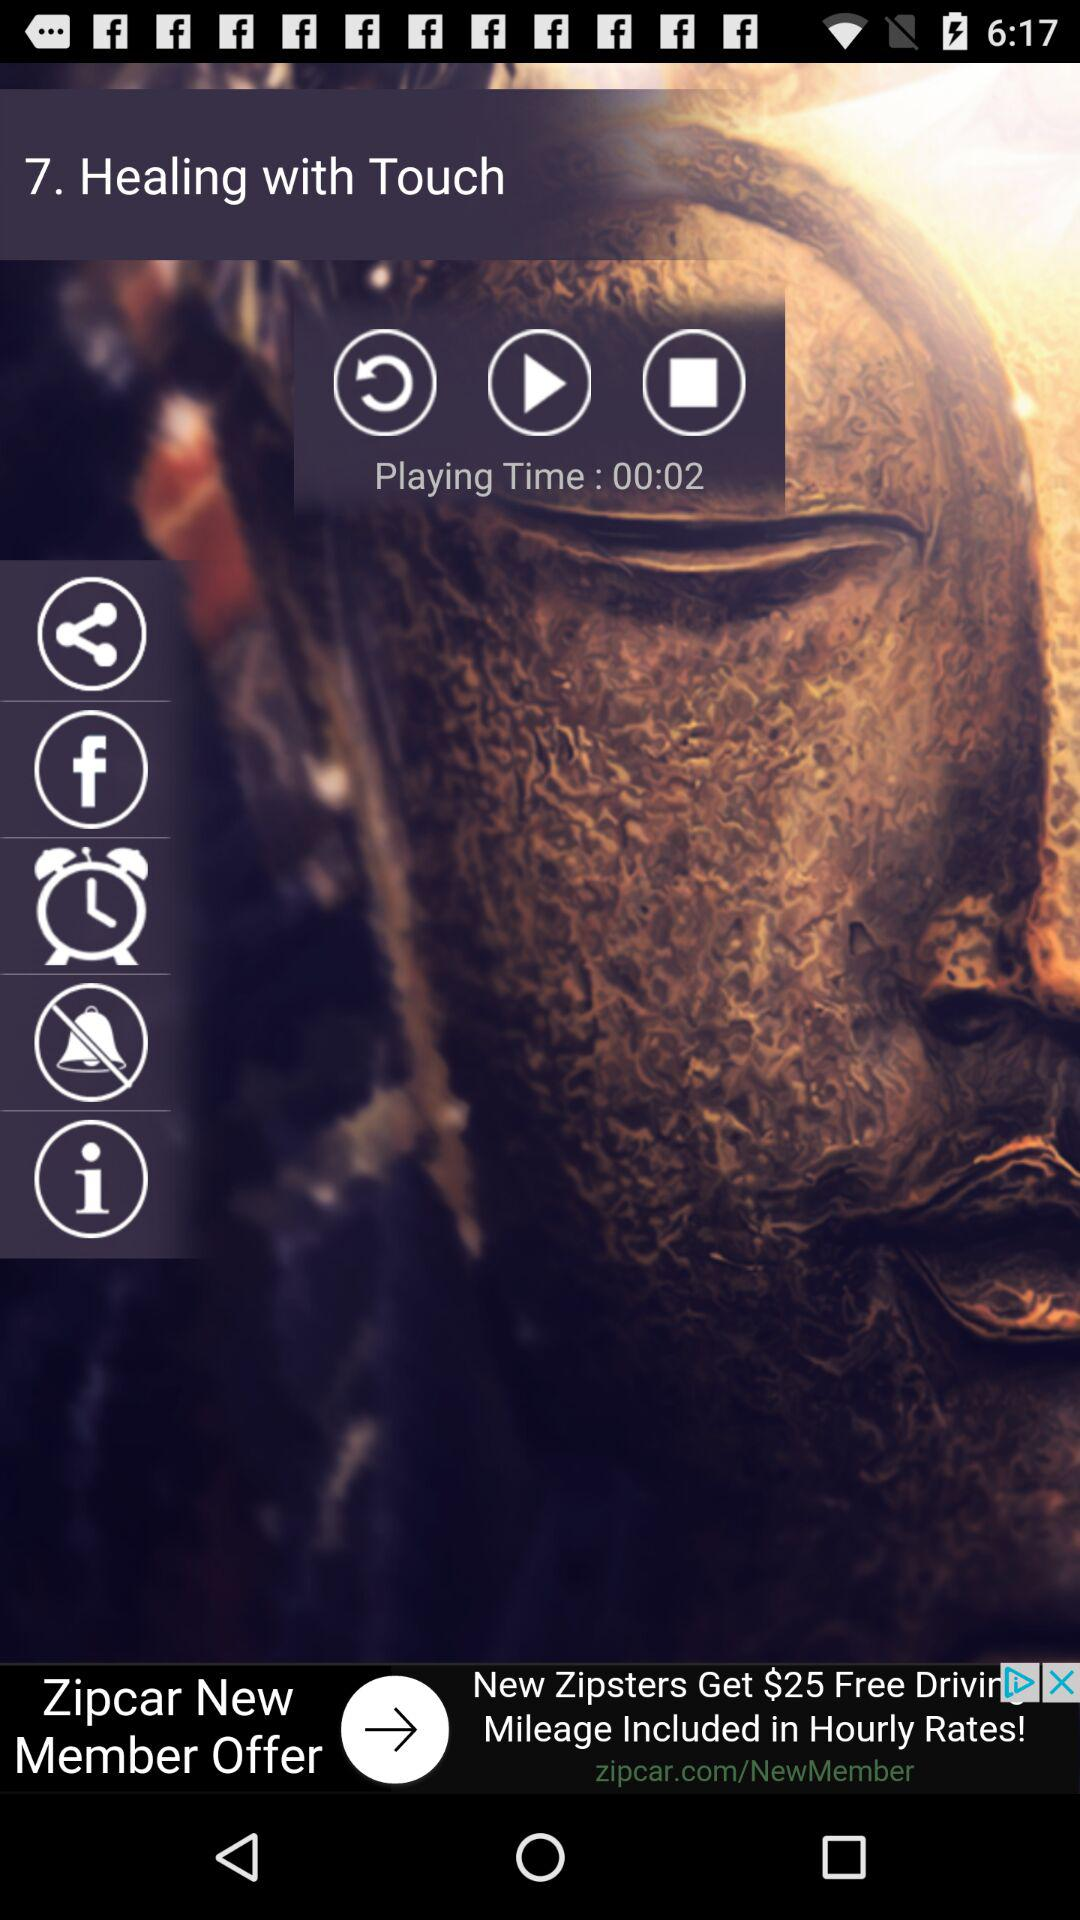What is the title of the song? The title of the song is "Healing with Touch". 